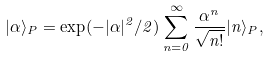Convert formula to latex. <formula><loc_0><loc_0><loc_500><loc_500>| \alpha \rangle _ { P } = \exp ( - | \alpha | ^ { 2 } / 2 ) \sum _ { n = 0 } ^ { \infty } \frac { \alpha ^ { n } } { \sqrt { n ! } } | n \rangle _ { P } ,</formula> 